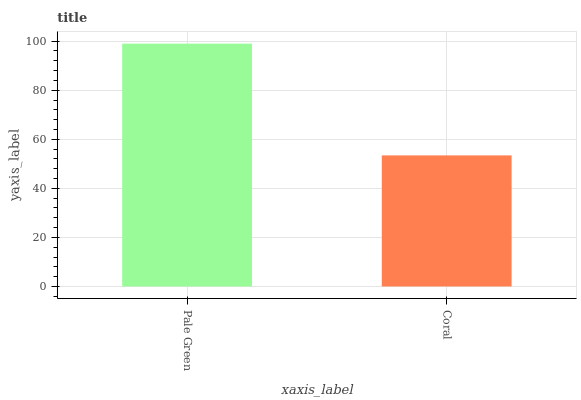Is Coral the minimum?
Answer yes or no. Yes. Is Pale Green the maximum?
Answer yes or no. Yes. Is Coral the maximum?
Answer yes or no. No. Is Pale Green greater than Coral?
Answer yes or no. Yes. Is Coral less than Pale Green?
Answer yes or no. Yes. Is Coral greater than Pale Green?
Answer yes or no. No. Is Pale Green less than Coral?
Answer yes or no. No. Is Pale Green the high median?
Answer yes or no. Yes. Is Coral the low median?
Answer yes or no. Yes. Is Coral the high median?
Answer yes or no. No. Is Pale Green the low median?
Answer yes or no. No. 